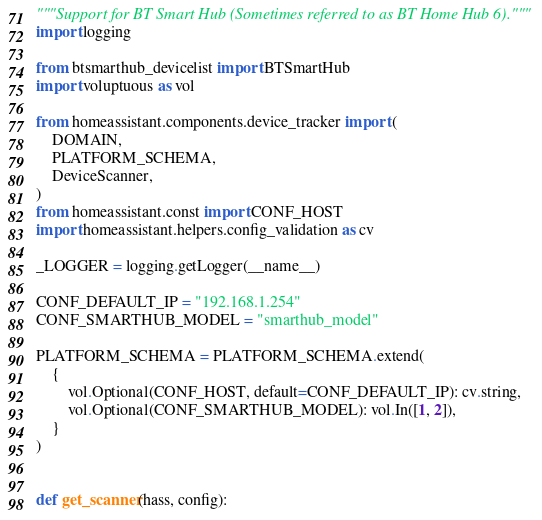Convert code to text. <code><loc_0><loc_0><loc_500><loc_500><_Python_>"""Support for BT Smart Hub (Sometimes referred to as BT Home Hub 6)."""
import logging

from btsmarthub_devicelist import BTSmartHub
import voluptuous as vol

from homeassistant.components.device_tracker import (
    DOMAIN,
    PLATFORM_SCHEMA,
    DeviceScanner,
)
from homeassistant.const import CONF_HOST
import homeassistant.helpers.config_validation as cv

_LOGGER = logging.getLogger(__name__)

CONF_DEFAULT_IP = "192.168.1.254"
CONF_SMARTHUB_MODEL = "smarthub_model"

PLATFORM_SCHEMA = PLATFORM_SCHEMA.extend(
    {
        vol.Optional(CONF_HOST, default=CONF_DEFAULT_IP): cv.string,
        vol.Optional(CONF_SMARTHUB_MODEL): vol.In([1, 2]),
    }
)


def get_scanner(hass, config):</code> 